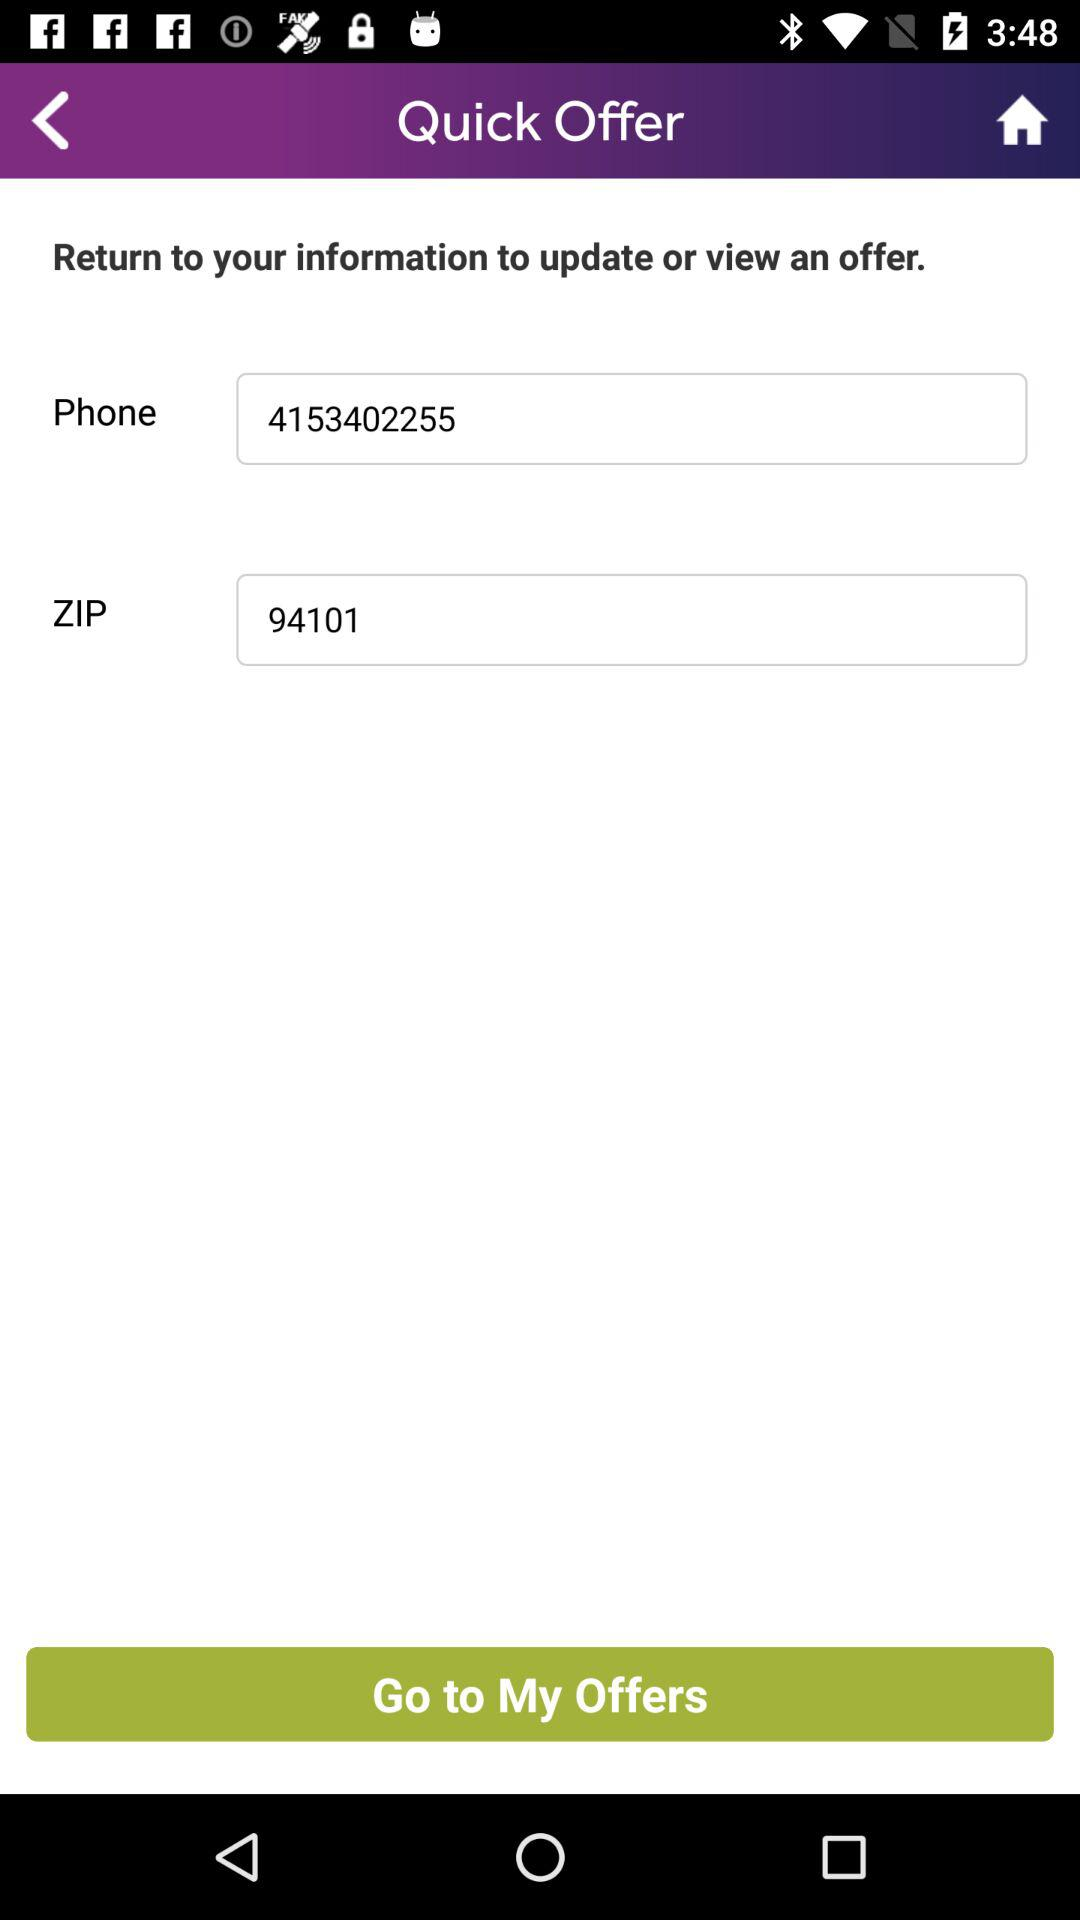What is the zip code? The zip code is 94101. 